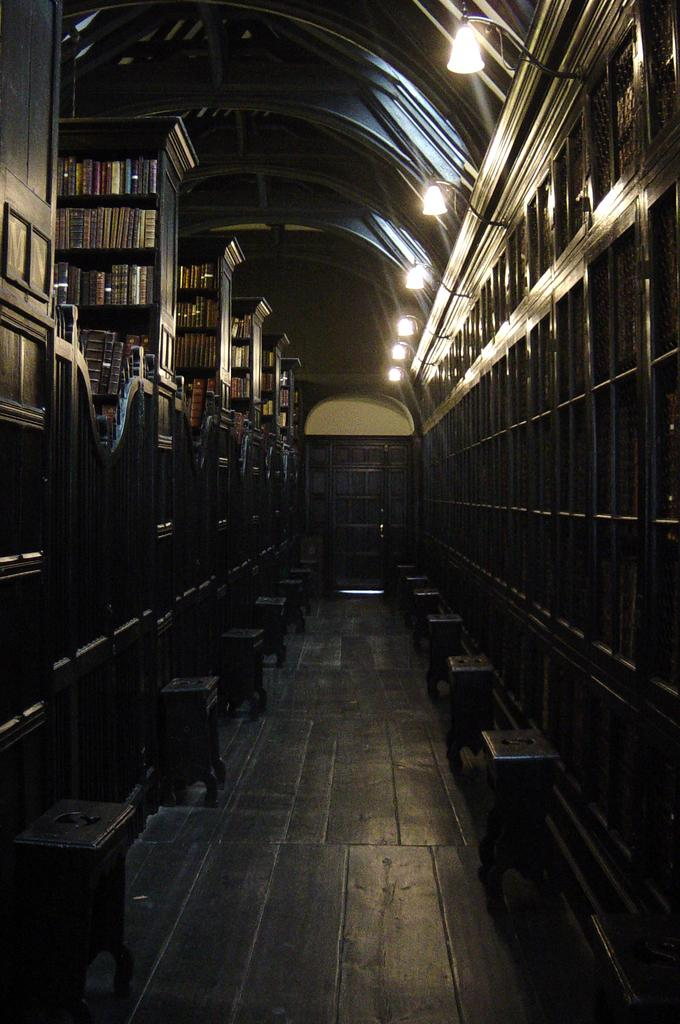What type of location is depicted in the image? The image is an inside view of a building. What type of furniture can be seen in the image? There are stools in the image. What items are stored on the shelves in the image? There are books in shelves in the image. What type of illumination is present in the image? There are lights in the image. What part of the building can be seen at the top of the image? The roof is visible at the top of the image. Can you hear the books crying in the image? There are no sounds or emotions associated with the books in the image, so it is not possible to hear them crying. 